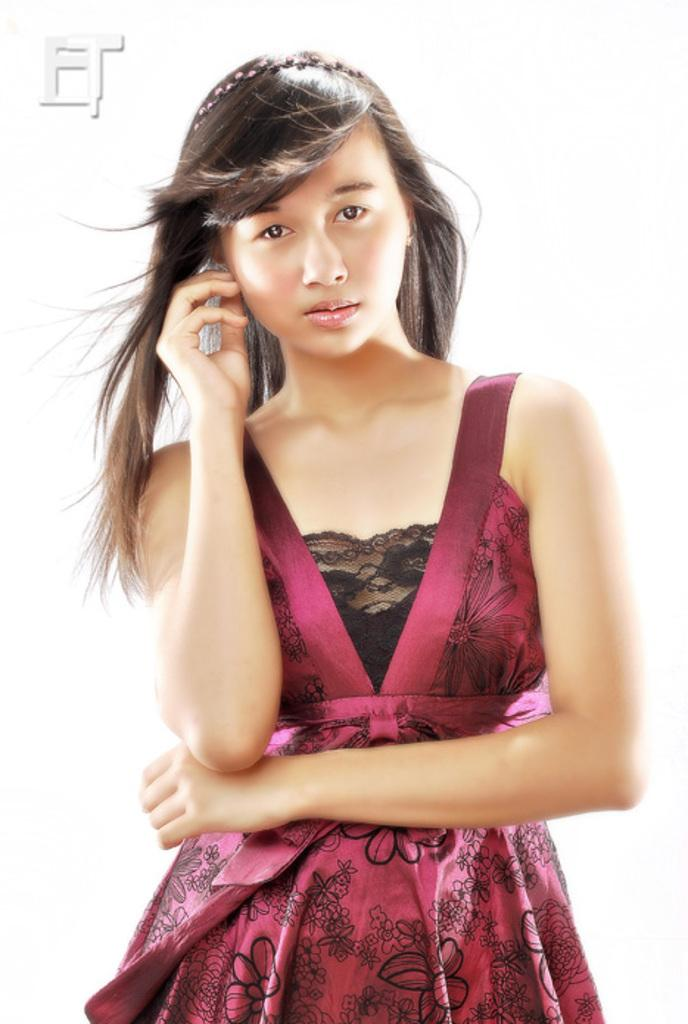What is the color of the background in the image? The background of the picture is white. Can you describe the person in the image? There is a woman in the image. What is the woman wearing? The woman is wearing a dress. What is the woman doing in the image? The woman is giving a pose. What accessory can be seen on the woman's head? There is a hair band on the woman's head. Can you see a parrot perched on the car's roof in the image? No, there is no parrot present in the image. Is there a sandcastle being built on the side of the road in the image? No, there is no sandcastle present in the image. Is there a volcano erupting in the background of the image? No, there is no volcano present in the image. 